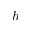<formula> <loc_0><loc_0><loc_500><loc_500>h</formula> 